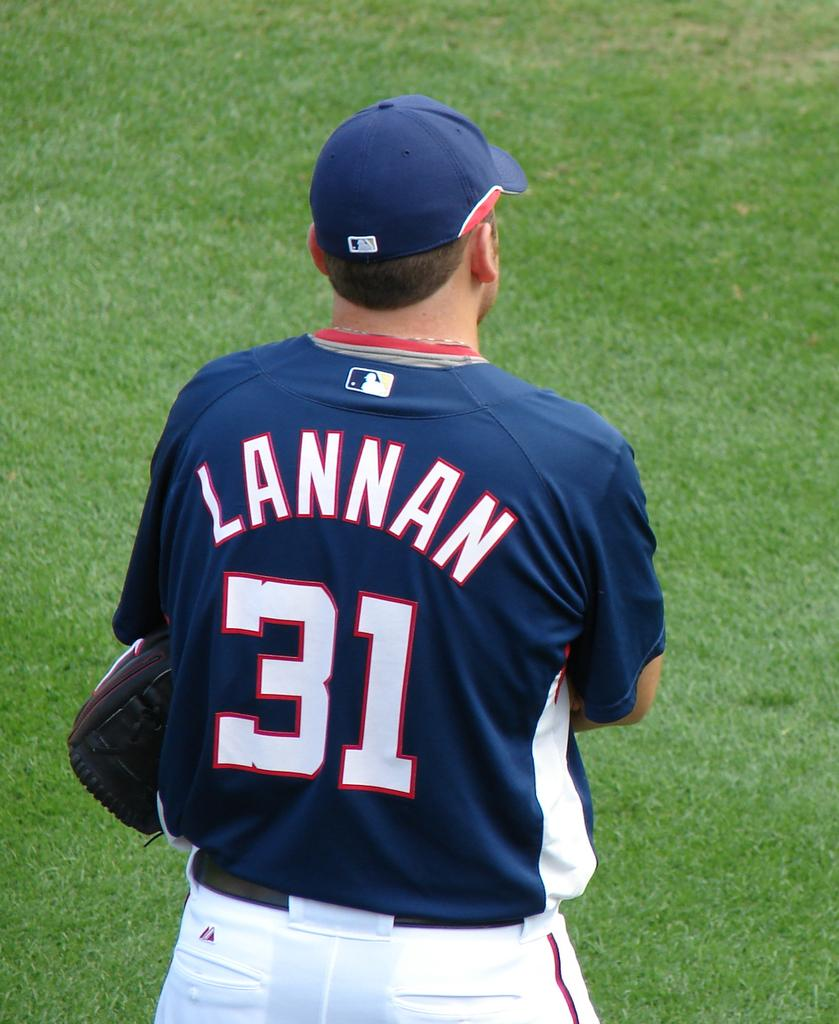<image>
Share a concise interpretation of the image provided. Lannan wearing his jersey that is number 31 